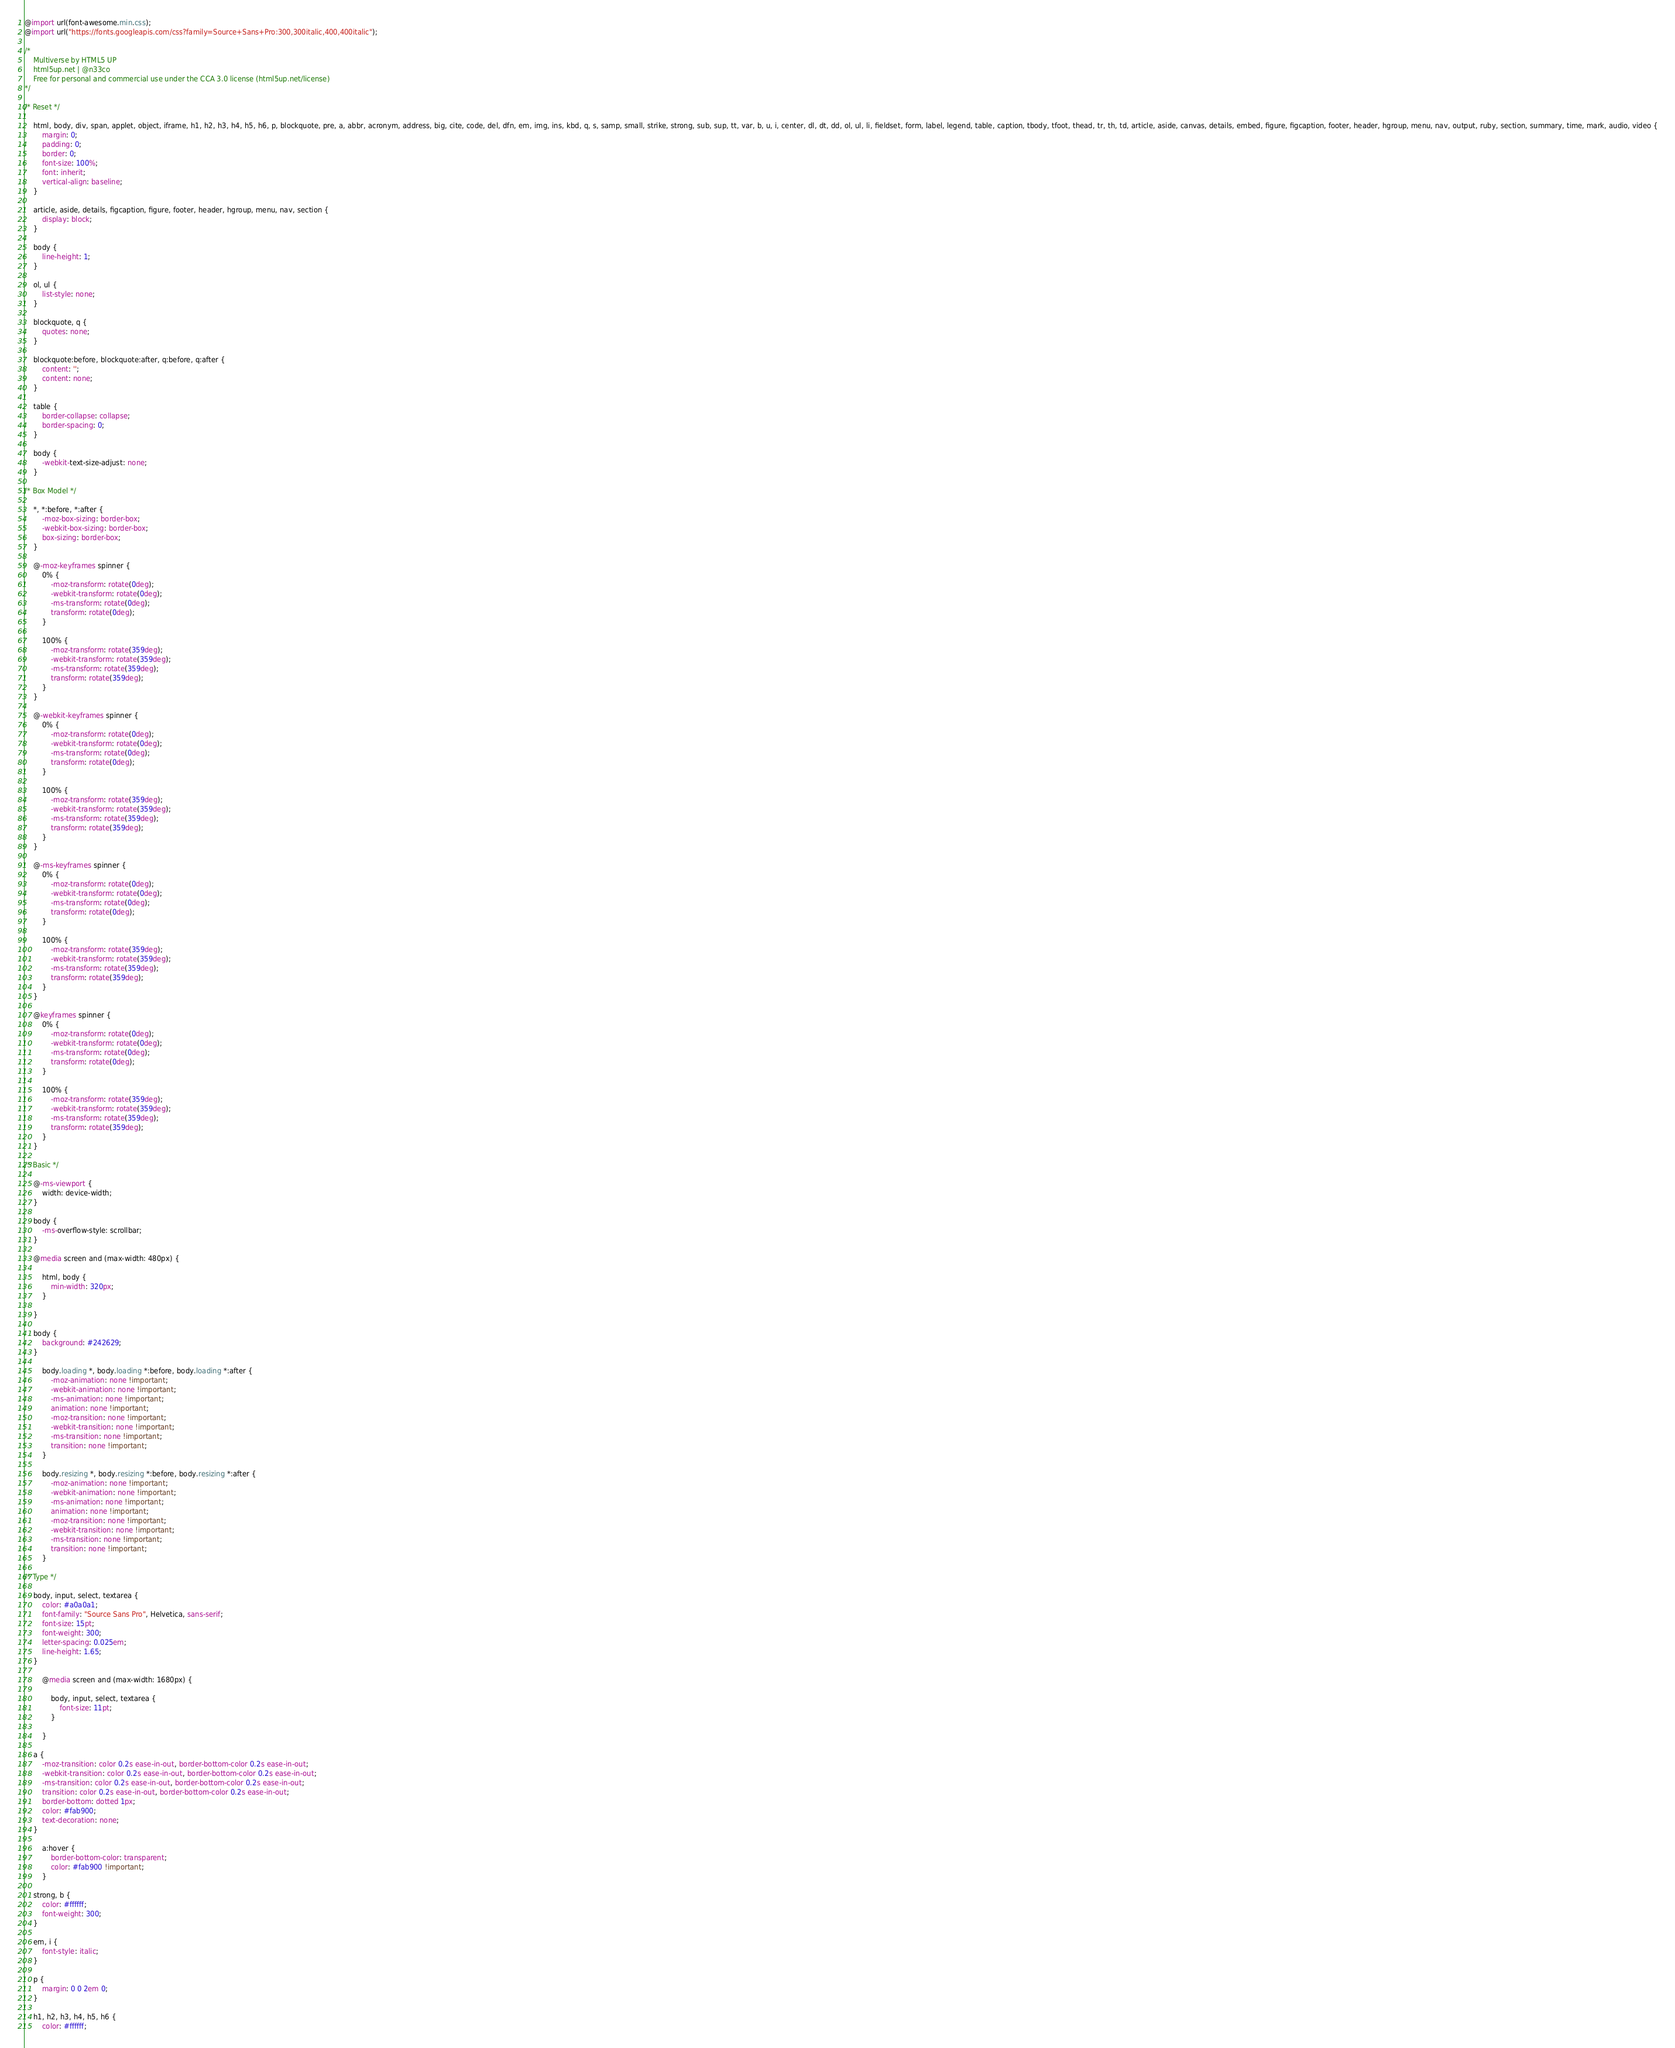<code> <loc_0><loc_0><loc_500><loc_500><_CSS_>@import url(font-awesome.min.css);
@import url("https://fonts.googleapis.com/css?family=Source+Sans+Pro:300,300italic,400,400italic");

/*
	Multiverse by HTML5 UP
	html5up.net | @n33co
	Free for personal and commercial use under the CCA 3.0 license (html5up.net/license)
*/

/* Reset */

	html, body, div, span, applet, object, iframe, h1, h2, h3, h4, h5, h6, p, blockquote, pre, a, abbr, acronym, address, big, cite, code, del, dfn, em, img, ins, kbd, q, s, samp, small, strike, strong, sub, sup, tt, var, b, u, i, center, dl, dt, dd, ol, ul, li, fieldset, form, label, legend, table, caption, tbody, tfoot, thead, tr, th, td, article, aside, canvas, details, embed, figure, figcaption, footer, header, hgroup, menu, nav, output, ruby, section, summary, time, mark, audio, video {
		margin: 0;
		padding: 0;
		border: 0;
		font-size: 100%;
		font: inherit;
		vertical-align: baseline;
	}

	article, aside, details, figcaption, figure, footer, header, hgroup, menu, nav, section {
		display: block;
	}

	body {
		line-height: 1;
	}

	ol, ul {
		list-style: none;
	}

	blockquote, q {
		quotes: none;
	}

	blockquote:before, blockquote:after, q:before, q:after {
		content: '';
		content: none;
	}

	table {
		border-collapse: collapse;
		border-spacing: 0;
	}

	body {
		-webkit-text-size-adjust: none;
	}

/* Box Model */

	*, *:before, *:after {
		-moz-box-sizing: border-box;
		-webkit-box-sizing: border-box;
		box-sizing: border-box;
	}

	@-moz-keyframes spinner {
		0% {
			-moz-transform: rotate(0deg);
			-webkit-transform: rotate(0deg);
			-ms-transform: rotate(0deg);
			transform: rotate(0deg);
		}

		100% {
			-moz-transform: rotate(359deg);
			-webkit-transform: rotate(359deg);
			-ms-transform: rotate(359deg);
			transform: rotate(359deg);
		}
	}

	@-webkit-keyframes spinner {
		0% {
			-moz-transform: rotate(0deg);
			-webkit-transform: rotate(0deg);
			-ms-transform: rotate(0deg);
			transform: rotate(0deg);
		}

		100% {
			-moz-transform: rotate(359deg);
			-webkit-transform: rotate(359deg);
			-ms-transform: rotate(359deg);
			transform: rotate(359deg);
		}
	}

	@-ms-keyframes spinner {
		0% {
			-moz-transform: rotate(0deg);
			-webkit-transform: rotate(0deg);
			-ms-transform: rotate(0deg);
			transform: rotate(0deg);
		}

		100% {
			-moz-transform: rotate(359deg);
			-webkit-transform: rotate(359deg);
			-ms-transform: rotate(359deg);
			transform: rotate(359deg);
		}
	}

	@keyframes spinner {
		0% {
			-moz-transform: rotate(0deg);
			-webkit-transform: rotate(0deg);
			-ms-transform: rotate(0deg);
			transform: rotate(0deg);
		}

		100% {
			-moz-transform: rotate(359deg);
			-webkit-transform: rotate(359deg);
			-ms-transform: rotate(359deg);
			transform: rotate(359deg);
		}
	}

/* Basic */

	@-ms-viewport {
		width: device-width;
	}

	body {
		-ms-overflow-style: scrollbar;
	}

	@media screen and (max-width: 480px) {

		html, body {
			min-width: 320px;
		}

	}

	body {
		background: #242629;
	}

		body.loading *, body.loading *:before, body.loading *:after {
			-moz-animation: none !important;
			-webkit-animation: none !important;
			-ms-animation: none !important;
			animation: none !important;
			-moz-transition: none !important;
			-webkit-transition: none !important;
			-ms-transition: none !important;
			transition: none !important;
		}

		body.resizing *, body.resizing *:before, body.resizing *:after {
			-moz-animation: none !important;
			-webkit-animation: none !important;
			-ms-animation: none !important;
			animation: none !important;
			-moz-transition: none !important;
			-webkit-transition: none !important;
			-ms-transition: none !important;
			transition: none !important;
		}

/* Type */

	body, input, select, textarea {
		color: #a0a0a1;
		font-family: "Source Sans Pro", Helvetica, sans-serif;
		font-size: 15pt;
		font-weight: 300;
		letter-spacing: 0.025em;
		line-height: 1.65;
	}

		@media screen and (max-width: 1680px) {

			body, input, select, textarea {
				font-size: 11pt;
			}

		}

	a {
		-moz-transition: color 0.2s ease-in-out, border-bottom-color 0.2s ease-in-out;
		-webkit-transition: color 0.2s ease-in-out, border-bottom-color 0.2s ease-in-out;
		-ms-transition: color 0.2s ease-in-out, border-bottom-color 0.2s ease-in-out;
		transition: color 0.2s ease-in-out, border-bottom-color 0.2s ease-in-out;
		border-bottom: dotted 1px;
		color: #fab900;
		text-decoration: none;
	}

		a:hover {
			border-bottom-color: transparent;
			color: #fab900 !important;
		}

	strong, b {
		color: #ffffff;
		font-weight: 300;
	}

	em, i {
		font-style: italic;
	}

	p {
		margin: 0 0 2em 0;
	}

	h1, h2, h3, h4, h5, h6 {
		color: #ffffff;</code> 